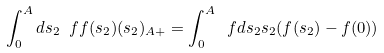<formula> <loc_0><loc_0><loc_500><loc_500>\int _ { 0 } ^ { A } d s _ { 2 } \ f { f ( s _ { 2 } ) } { ( s _ { 2 } ) _ { A + } } = \int _ { 0 } ^ { A } \ f { d s _ { 2 } } { s _ { 2 } } ( f ( s _ { 2 } ) - f ( 0 ) )</formula> 